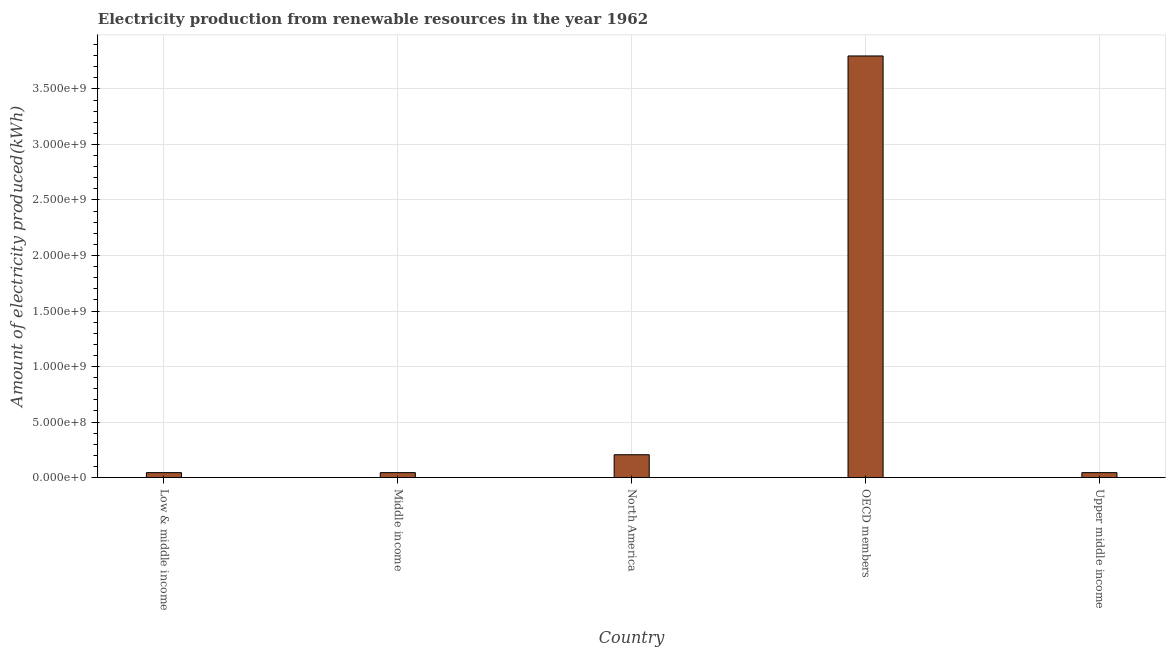Does the graph contain grids?
Offer a terse response. Yes. What is the title of the graph?
Offer a terse response. Electricity production from renewable resources in the year 1962. What is the label or title of the X-axis?
Give a very brief answer. Country. What is the label or title of the Y-axis?
Your answer should be very brief. Amount of electricity produced(kWh). What is the amount of electricity produced in Low & middle income?
Make the answer very short. 4.50e+07. Across all countries, what is the maximum amount of electricity produced?
Give a very brief answer. 3.80e+09. Across all countries, what is the minimum amount of electricity produced?
Give a very brief answer. 4.50e+07. In which country was the amount of electricity produced maximum?
Provide a short and direct response. OECD members. What is the sum of the amount of electricity produced?
Keep it short and to the point. 4.14e+09. What is the difference between the amount of electricity produced in Low & middle income and Middle income?
Your response must be concise. 0. What is the average amount of electricity produced per country?
Offer a very short reply. 8.28e+08. What is the median amount of electricity produced?
Your answer should be very brief. 4.50e+07. What is the ratio of the amount of electricity produced in Low & middle income to that in OECD members?
Make the answer very short. 0.01. What is the difference between the highest and the second highest amount of electricity produced?
Give a very brief answer. 3.59e+09. Is the sum of the amount of electricity produced in OECD members and Upper middle income greater than the maximum amount of electricity produced across all countries?
Provide a short and direct response. Yes. What is the difference between the highest and the lowest amount of electricity produced?
Ensure brevity in your answer.  3.75e+09. How many bars are there?
Ensure brevity in your answer.  5. What is the Amount of electricity produced(kWh) in Low & middle income?
Make the answer very short. 4.50e+07. What is the Amount of electricity produced(kWh) of Middle income?
Your response must be concise. 4.50e+07. What is the Amount of electricity produced(kWh) in North America?
Your answer should be very brief. 2.06e+08. What is the Amount of electricity produced(kWh) of OECD members?
Make the answer very short. 3.80e+09. What is the Amount of electricity produced(kWh) of Upper middle income?
Your answer should be compact. 4.50e+07. What is the difference between the Amount of electricity produced(kWh) in Low & middle income and North America?
Make the answer very short. -1.61e+08. What is the difference between the Amount of electricity produced(kWh) in Low & middle income and OECD members?
Give a very brief answer. -3.75e+09. What is the difference between the Amount of electricity produced(kWh) in Middle income and North America?
Your answer should be compact. -1.61e+08. What is the difference between the Amount of electricity produced(kWh) in Middle income and OECD members?
Provide a succinct answer. -3.75e+09. What is the difference between the Amount of electricity produced(kWh) in Middle income and Upper middle income?
Give a very brief answer. 0. What is the difference between the Amount of electricity produced(kWh) in North America and OECD members?
Your answer should be very brief. -3.59e+09. What is the difference between the Amount of electricity produced(kWh) in North America and Upper middle income?
Make the answer very short. 1.61e+08. What is the difference between the Amount of electricity produced(kWh) in OECD members and Upper middle income?
Your answer should be compact. 3.75e+09. What is the ratio of the Amount of electricity produced(kWh) in Low & middle income to that in North America?
Offer a very short reply. 0.22. What is the ratio of the Amount of electricity produced(kWh) in Low & middle income to that in OECD members?
Ensure brevity in your answer.  0.01. What is the ratio of the Amount of electricity produced(kWh) in Low & middle income to that in Upper middle income?
Your answer should be very brief. 1. What is the ratio of the Amount of electricity produced(kWh) in Middle income to that in North America?
Your answer should be very brief. 0.22. What is the ratio of the Amount of electricity produced(kWh) in Middle income to that in OECD members?
Offer a very short reply. 0.01. What is the ratio of the Amount of electricity produced(kWh) in North America to that in OECD members?
Keep it short and to the point. 0.05. What is the ratio of the Amount of electricity produced(kWh) in North America to that in Upper middle income?
Your response must be concise. 4.58. What is the ratio of the Amount of electricity produced(kWh) in OECD members to that in Upper middle income?
Your answer should be compact. 84.38. 